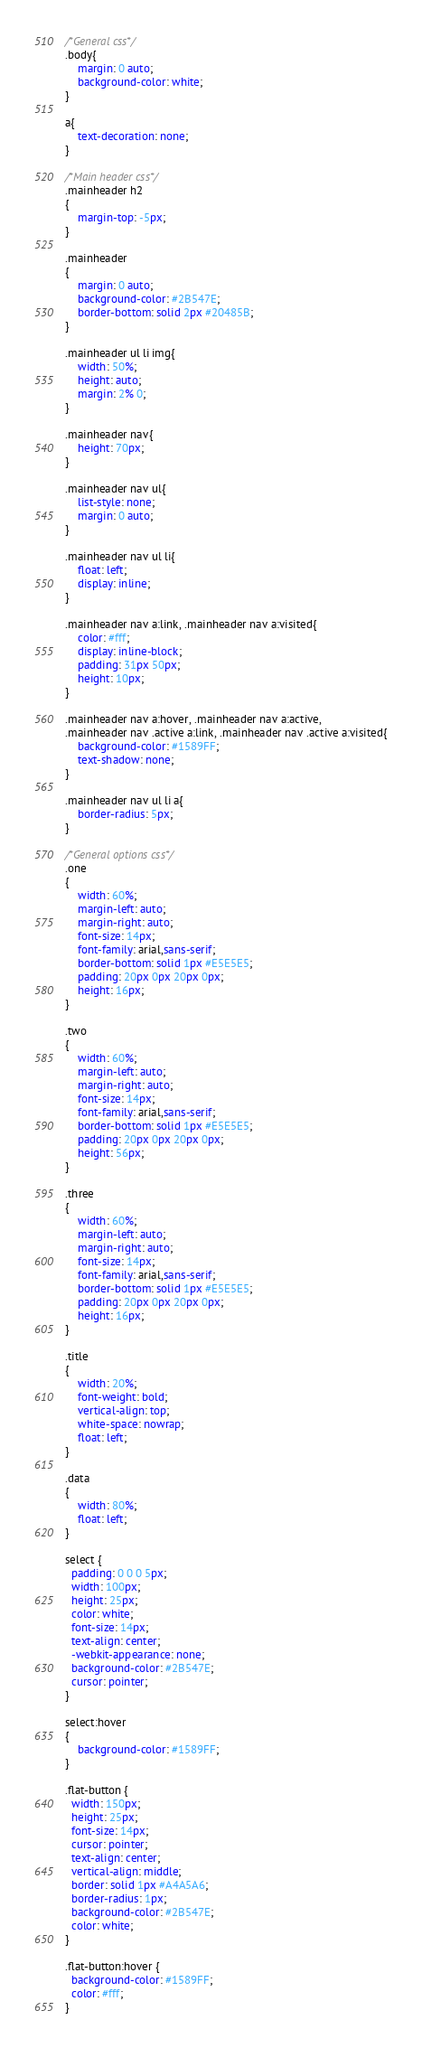<code> <loc_0><loc_0><loc_500><loc_500><_CSS_>/*General css*/
.body{
	margin: 0 auto;
	background-color: white;
}

a{
	text-decoration: none;
}

/*Main header css*/
.mainheader h2
{
	margin-top: -5px;
}

.mainheader
{
	margin: 0 auto;
	background-color: #2B547E;
	border-bottom: solid 2px #20485B;
}

.mainheader ul li img{
	width: 50%;
	height: auto;
	margin: 2% 0;
}

.mainheader nav{
	height: 70px;
}

.mainheader nav ul{
	list-style: none;
	margin: 0 auto;
}

.mainheader nav ul li{
	float: left;
	display: inline;
}

.mainheader nav a:link, .mainheader nav a:visited{
	color: #fff;
	display: inline-block;
	padding: 31px 50px;
	height: 10px;
}

.mainheader nav a:hover, .mainheader nav a:active,
.mainheader nav .active a:link, .mainheader nav .active a:visited{
	background-color: #1589FF;
	text-shadow: none;
} 

.mainheader nav ul li a{
	border-radius: 5px;
}

/*General options css*/
.one
{
	width: 60%;
	margin-left: auto;
	margin-right: auto;
   	font-size: 14px;
  	font-family: arial,sans-serif;
  	border-bottom: solid 1px #E5E5E5;
  	padding: 20px 0px 20px 0px;
  	height: 16px;
}

.two
{
	width: 60%;
	margin-left: auto;
	margin-right: auto;
   	font-size: 14px;
  	font-family: arial,sans-serif;
  	border-bottom: solid 1px #E5E5E5;
  	padding: 20px 0px 20px 0px;
  	height: 56px;
}

.three
{
	width: 60%;
	margin-left: auto;
	margin-right: auto;
   	font-size: 14px;
  	font-family: arial,sans-serif;
  	border-bottom: solid 1px #E5E5E5;
  	padding: 20px 0px 20px 0px;
  	height: 16px;
}

.title
{
	width: 20%;
	font-weight: bold;
	vertical-align: top;
	white-space: nowrap;
	float: left;
}

.data
{
	width: 80%;
	float: left;
}

select {
  padding: 0 0 0 5px;
  width: 100px;
  height: 25px;
  color: white;
  font-size: 14px;
  text-align: center;
  -webkit-appearance: none;
  background-color: #2B547E;
  cursor: pointer;
}

select:hover
{
	background-color: #1589FF;
}

.flat-button {
  width: 150px;
  height: 25px;
  font-size: 14px;
  cursor: pointer;
  text-align: center;
  vertical-align: middle;
  border: solid 1px #A4A5A6;
  border-radius: 1px;
  background-color: #2B547E;
  color: white;
}

.flat-button:hover {
  background-color: #1589FF;
  color: #fff;
}</code> 